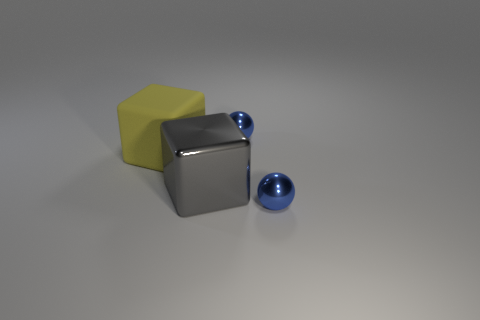Subtract all gray cubes. How many cubes are left? 1 Add 4 green spheres. How many objects exist? 8 Subtract 1 balls. How many balls are left? 1 Add 2 spheres. How many spheres exist? 4 Subtract 0 red cylinders. How many objects are left? 4 Subtract all gray blocks. Subtract all green cylinders. How many blocks are left? 1 Subtract all purple cylinders. How many gray blocks are left? 1 Subtract all large gray things. Subtract all metallic objects. How many objects are left? 0 Add 3 tiny metallic things. How many tiny metallic things are left? 5 